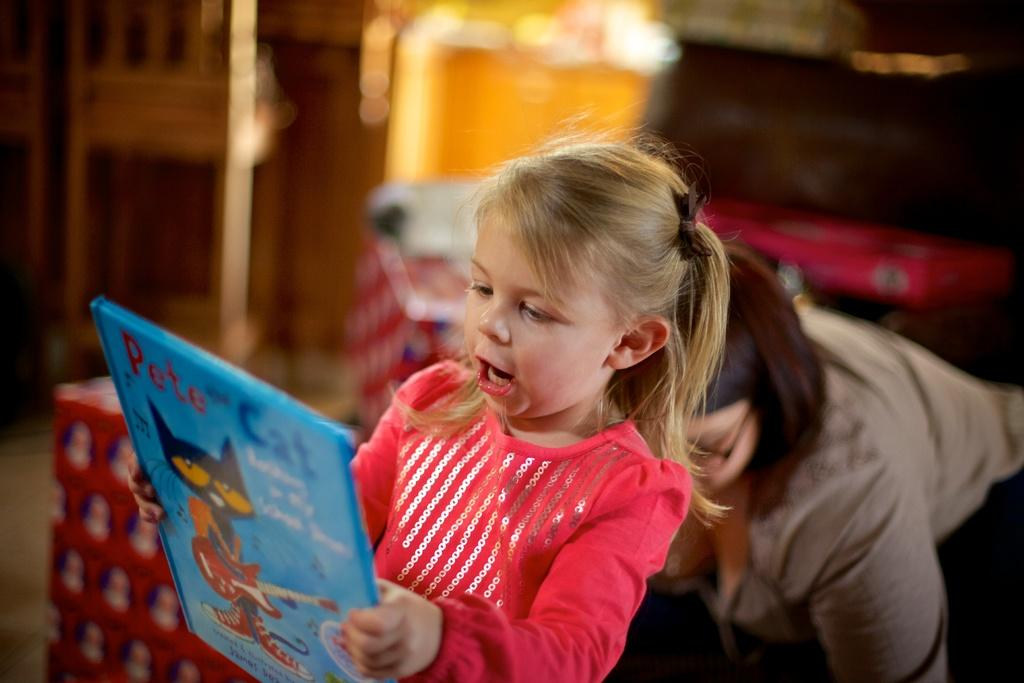Who is the main subject in the image? There is a little girl in the image. What is the little girl holding in the image? The girl is holding a blue book. Can you describe the background of the image? There is a woman in the background of the image. What type of crayon is the little girl using to color in the image? There is no crayon present in the image; the little girl is holding a blue book. 